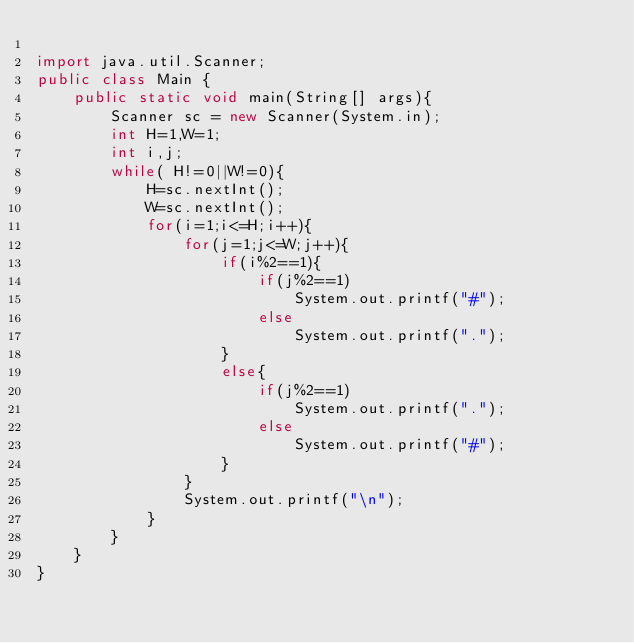<code> <loc_0><loc_0><loc_500><loc_500><_Java_>
import java.util.Scanner;
public class Main {
	public static void main(String[] args){
		Scanner sc = new Scanner(System.in);
		int H=1,W=1;
		int i,j;
		while( H!=0||W!=0){
			H=sc.nextInt();
			W=sc.nextInt();
			for(i=1;i<=H;i++){
				for(j=1;j<=W;j++){
					if(i%2==1){
						if(j%2==1)
							System.out.printf("#");
						else
							System.out.printf(".");
					}
					else{
						if(j%2==1)
							System.out.printf(".");
						else
							System.out.printf("#");
					}
				}
				System.out.printf("\n");
			}
		}
	}
}</code> 